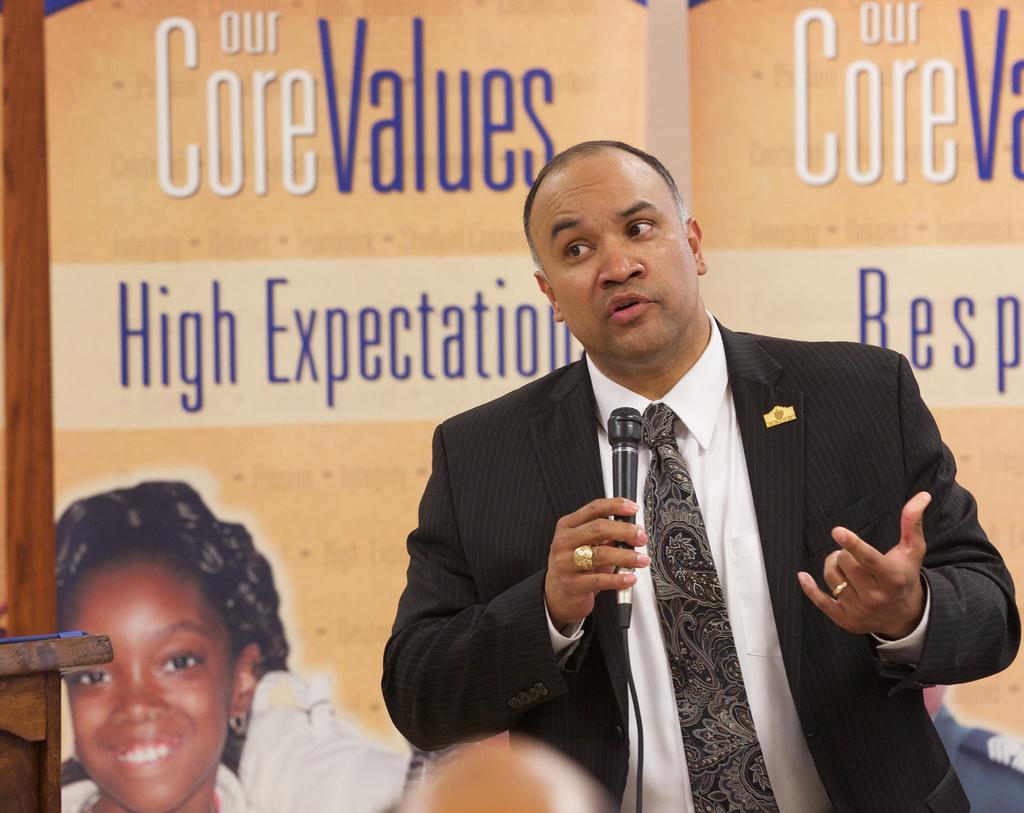In one or two sentences, can you explain what this image depicts? In the center of the image we can see a man standing and holding a mic in his hand. In the background there is a board. On the left there is a table. 